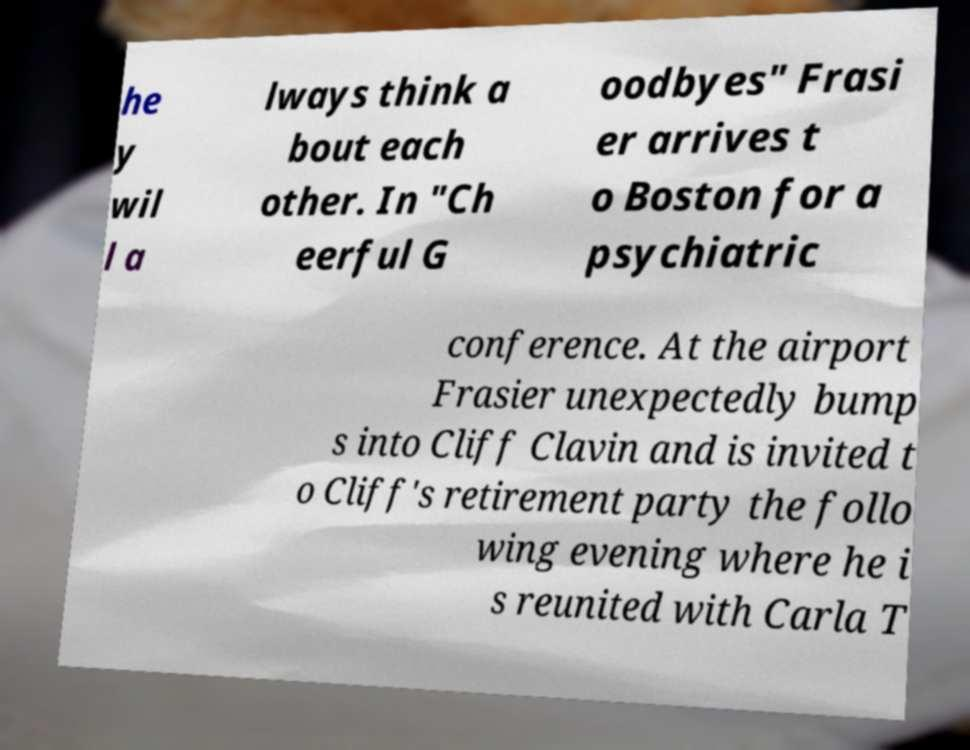Please read and relay the text visible in this image. What does it say? he y wil l a lways think a bout each other. In "Ch eerful G oodbyes" Frasi er arrives t o Boston for a psychiatric conference. At the airport Frasier unexpectedly bump s into Cliff Clavin and is invited t o Cliff's retirement party the follo wing evening where he i s reunited with Carla T 